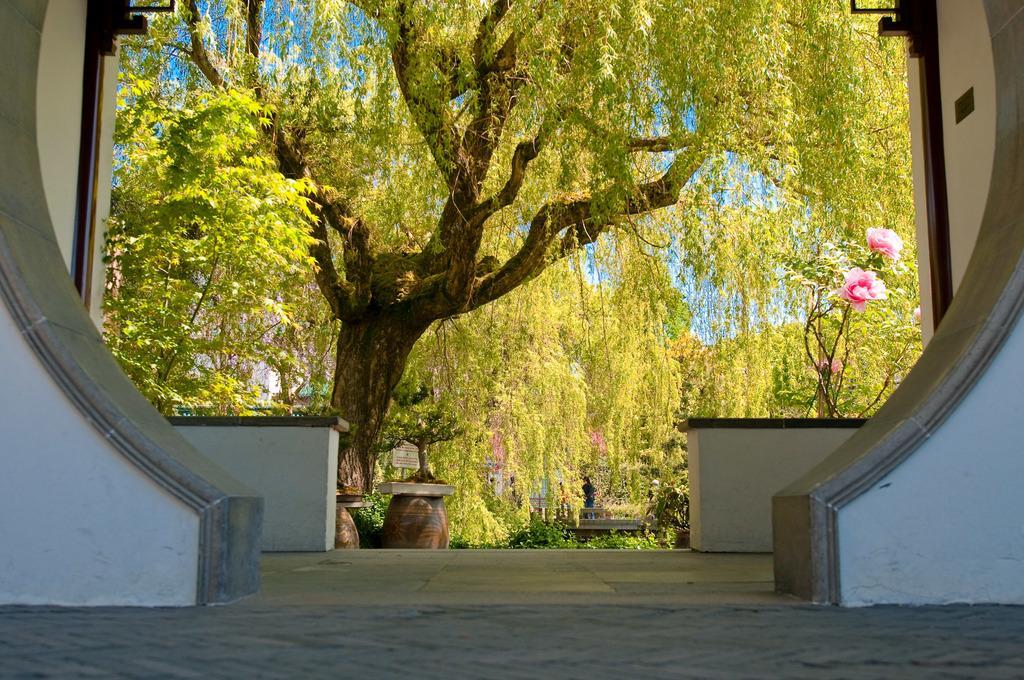How would you summarize this image in a sentence or two? This image consists of many trees and plants. To the right, there are flowers in pink color. At the bottom, there is a floor. To the left and right, there are walls. 